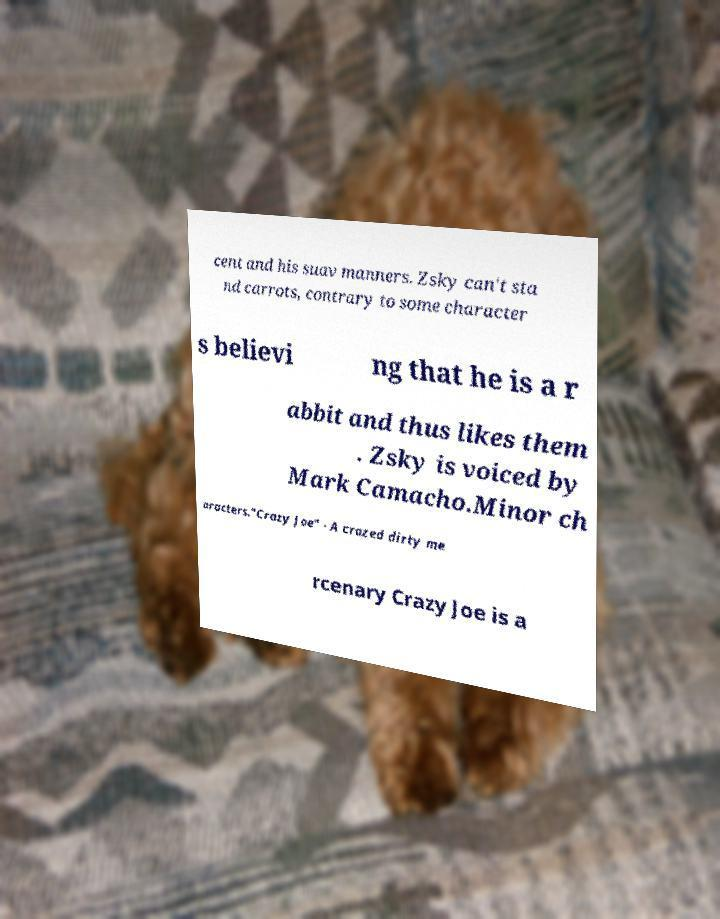What messages or text are displayed in this image? I need them in a readable, typed format. cent and his suav manners. Zsky can't sta nd carrots, contrary to some character s believi ng that he is a r abbit and thus likes them . Zsky is voiced by Mark Camacho.Minor ch aracters."Crazy Joe" - A crazed dirty me rcenary Crazy Joe is a 